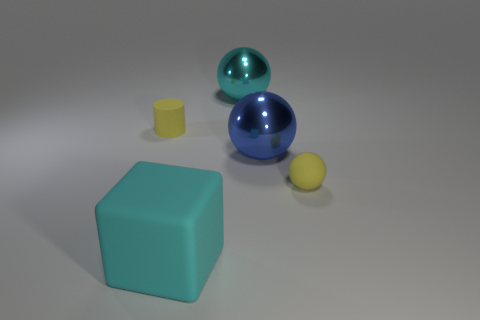Add 1 small things. How many objects exist? 6 Subtract all cylinders. How many objects are left? 4 Subtract 0 red cylinders. How many objects are left? 5 Subtract all large blocks. Subtract all gray balls. How many objects are left? 4 Add 2 big cyan shiny things. How many big cyan shiny things are left? 3 Add 2 yellow matte cylinders. How many yellow matte cylinders exist? 3 